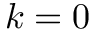Convert formula to latex. <formula><loc_0><loc_0><loc_500><loc_500>k = 0</formula> 